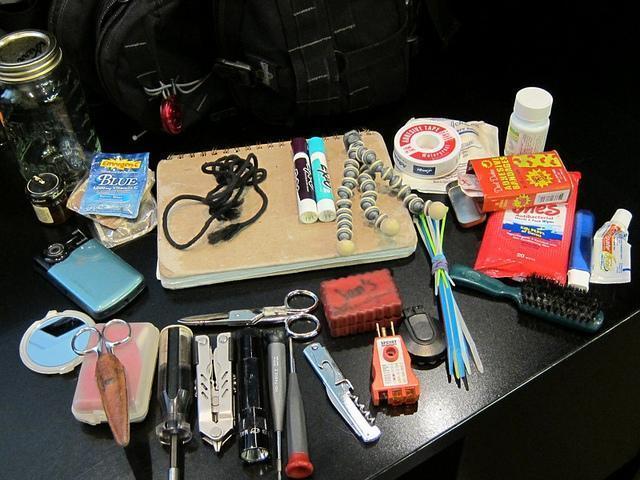How many markers are there?
Give a very brief answer. 2. How many toothbrushes?
Give a very brief answer. 0. How many scissors are there?
Give a very brief answer. 2. How many books are in the photo?
Give a very brief answer. 1. 